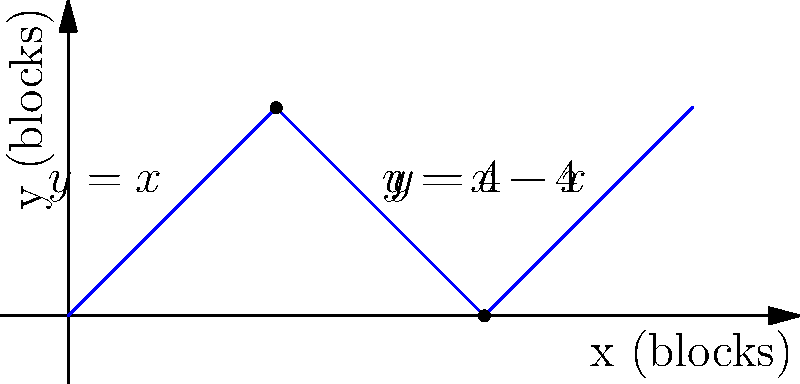As a tour guide in Brooklyn, you've designed a unique zigzag route through the city blocks to showcase the architecture. The path is represented by the piecewise function shown in the graph, where each unit represents one city block. Calculate the total distance walked during this tour. To calculate the total distance, we need to find the arc length of the piecewise function over the interval [0, 6]. We'll do this by breaking it down into three parts:

1) For $0 \leq x < 2$: $f(x) = x$
   Arc length: $\int_0^2 \sqrt{1 + (\frac{df}{dx})^2} dx = \int_0^2 \sqrt{1 + 1^2} dx = \sqrt{2} \cdot 2 = 2\sqrt{2}$

2) For $2 \leq x < 4$: $f(x) = 4-x$
   Arc length: $\int_2^4 \sqrt{1 + (-1)^2} dx = \sqrt{2} \cdot 2 = 2\sqrt{2}$

3) For $4 \leq x \leq 6$: $f(x) = x-4$
   Arc length: $\int_4^6 \sqrt{1 + 1^2} dx = \sqrt{2} \cdot 2 = 2\sqrt{2}$

Total distance = $2\sqrt{2} + 2\sqrt{2} + 2\sqrt{2} = 6\sqrt{2}$ blocks
Answer: $6\sqrt{2}$ blocks 